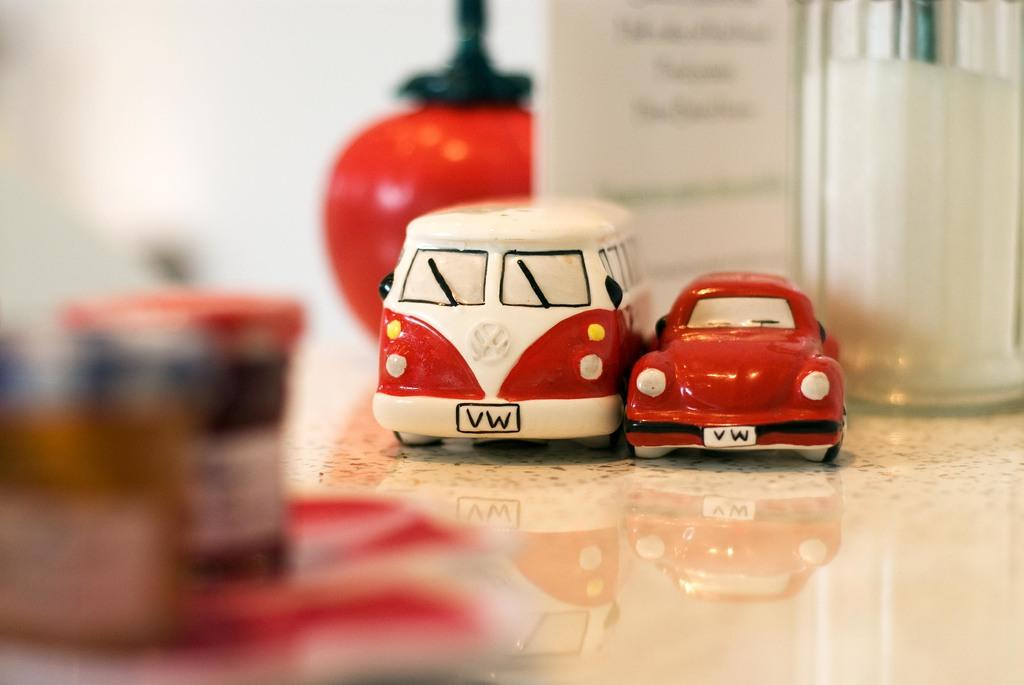What type of toys are present in the image? There are toy vehicles in the image. What else can be seen on the floor in the image? There are other objects on the floor in the image. What can be seen in the background of the image? There is a wall visible in the background of the image. Can you see any branches in the image? There are no branches present in the image. Are there any ants visible in the image? There are no ants visible in the image. 